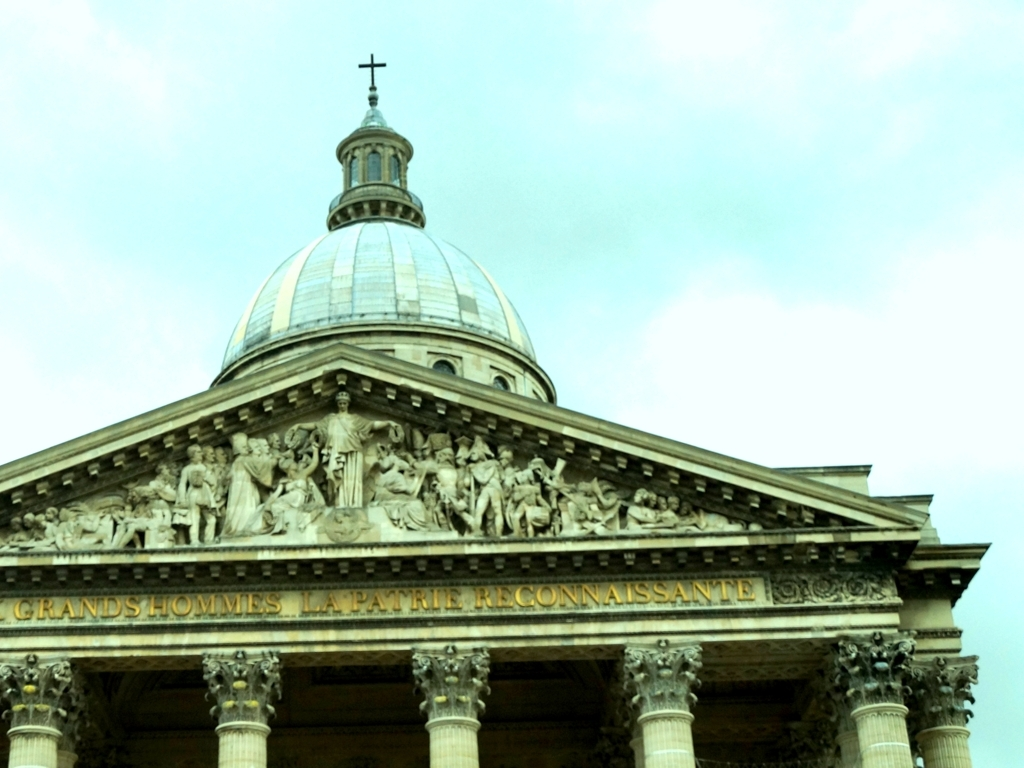Is there any text visible on the building, and what does it signify? The inscription 'AUX GRANDS HOMMES LA PATRIE RECONNAISSANTE' suggests that the building is a memorial or monument dedicated to great men to whom the nation is grateful. It underscores the building's purpose as a place of commemoration and honor. Can you give an insight into what period this building might be from? Based on its neoclassical design, which became a predominant architectural style starting from the mid-18th century and through the 19th century, we could infer that the building was constructed or at least designed during this period. 